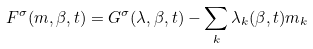<formula> <loc_0><loc_0><loc_500><loc_500>F ^ { \sigma } ( m , \beta , t ) = G ^ { \sigma } ( \lambda , \beta , t ) - \sum _ { k } \lambda _ { k } ( \beta , t ) m _ { k }</formula> 